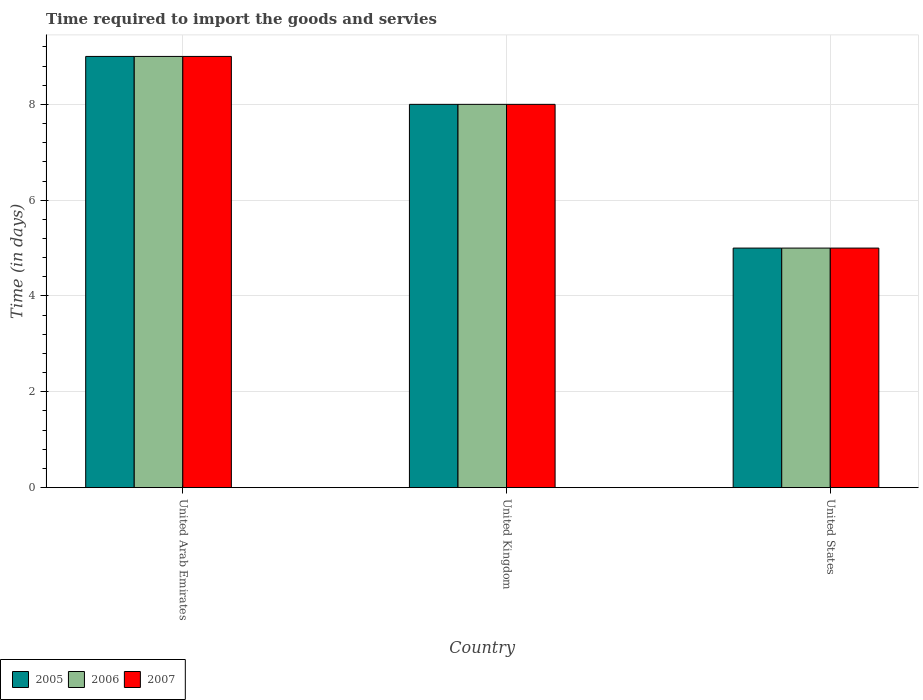Are the number of bars per tick equal to the number of legend labels?
Your answer should be compact. Yes. Are the number of bars on each tick of the X-axis equal?
Provide a succinct answer. Yes. How many bars are there on the 1st tick from the left?
Provide a succinct answer. 3. In how many cases, is the number of bars for a given country not equal to the number of legend labels?
Offer a terse response. 0. In which country was the number of days required to import the goods and services in 2006 maximum?
Make the answer very short. United Arab Emirates. What is the difference between the number of days required to import the goods and services in 2006 in United Kingdom and that in United States?
Your response must be concise. 3. What is the difference between the number of days required to import the goods and services in 2007 in United Arab Emirates and the number of days required to import the goods and services in 2005 in United Kingdom?
Make the answer very short. 1. What is the average number of days required to import the goods and services in 2005 per country?
Ensure brevity in your answer.  7.33. What is the difference between the number of days required to import the goods and services of/in 2005 and number of days required to import the goods and services of/in 2007 in United States?
Provide a short and direct response. 0. In how many countries, is the number of days required to import the goods and services in 2005 greater than 2.4 days?
Provide a succinct answer. 3. Is the difference between the number of days required to import the goods and services in 2005 in United Arab Emirates and United States greater than the difference between the number of days required to import the goods and services in 2007 in United Arab Emirates and United States?
Ensure brevity in your answer.  No. What is the difference between the highest and the lowest number of days required to import the goods and services in 2005?
Make the answer very short. 4. Is it the case that in every country, the sum of the number of days required to import the goods and services in 2007 and number of days required to import the goods and services in 2006 is greater than the number of days required to import the goods and services in 2005?
Your answer should be very brief. Yes. Are the values on the major ticks of Y-axis written in scientific E-notation?
Give a very brief answer. No. Does the graph contain any zero values?
Keep it short and to the point. No. Where does the legend appear in the graph?
Your response must be concise. Bottom left. What is the title of the graph?
Your response must be concise. Time required to import the goods and servies. Does "1993" appear as one of the legend labels in the graph?
Offer a terse response. No. What is the label or title of the X-axis?
Keep it short and to the point. Country. What is the label or title of the Y-axis?
Ensure brevity in your answer.  Time (in days). What is the Time (in days) of 2005 in United Arab Emirates?
Offer a terse response. 9. What is the Time (in days) in 2006 in United Arab Emirates?
Your answer should be compact. 9. What is the Time (in days) in 2005 in United Kingdom?
Your answer should be compact. 8. What is the Time (in days) in 2006 in United States?
Offer a terse response. 5. Across all countries, what is the maximum Time (in days) of 2007?
Give a very brief answer. 9. Across all countries, what is the minimum Time (in days) of 2006?
Your answer should be very brief. 5. What is the total Time (in days) in 2005 in the graph?
Make the answer very short. 22. What is the total Time (in days) of 2006 in the graph?
Offer a very short reply. 22. What is the difference between the Time (in days) of 2005 in United Arab Emirates and that in United Kingdom?
Offer a terse response. 1. What is the difference between the Time (in days) in 2007 in United Arab Emirates and that in United Kingdom?
Your response must be concise. 1. What is the difference between the Time (in days) in 2006 in United Kingdom and that in United States?
Your answer should be compact. 3. What is the difference between the Time (in days) of 2005 in United Arab Emirates and the Time (in days) of 2006 in United Kingdom?
Make the answer very short. 1. What is the difference between the Time (in days) in 2006 in United Arab Emirates and the Time (in days) in 2007 in United Kingdom?
Ensure brevity in your answer.  1. What is the difference between the Time (in days) of 2005 in United Arab Emirates and the Time (in days) of 2006 in United States?
Give a very brief answer. 4. What is the difference between the Time (in days) of 2006 in United Arab Emirates and the Time (in days) of 2007 in United States?
Make the answer very short. 4. What is the average Time (in days) of 2005 per country?
Make the answer very short. 7.33. What is the average Time (in days) of 2006 per country?
Provide a succinct answer. 7.33. What is the average Time (in days) of 2007 per country?
Give a very brief answer. 7.33. What is the difference between the Time (in days) of 2005 and Time (in days) of 2007 in United Kingdom?
Your answer should be very brief. 0. What is the difference between the Time (in days) in 2005 and Time (in days) in 2006 in United States?
Your response must be concise. 0. What is the difference between the Time (in days) of 2006 and Time (in days) of 2007 in United States?
Your answer should be very brief. 0. What is the ratio of the Time (in days) of 2005 in United Arab Emirates to that in United Kingdom?
Your response must be concise. 1.12. What is the ratio of the Time (in days) in 2007 in United Arab Emirates to that in United Kingdom?
Ensure brevity in your answer.  1.12. What is the ratio of the Time (in days) of 2005 in United Arab Emirates to that in United States?
Give a very brief answer. 1.8. What is the ratio of the Time (in days) in 2006 in United Arab Emirates to that in United States?
Your answer should be very brief. 1.8. What is the ratio of the Time (in days) in 2007 in United Arab Emirates to that in United States?
Your answer should be very brief. 1.8. What is the ratio of the Time (in days) in 2006 in United Kingdom to that in United States?
Keep it short and to the point. 1.6. What is the difference between the highest and the second highest Time (in days) in 2005?
Give a very brief answer. 1. What is the difference between the highest and the second highest Time (in days) of 2006?
Your answer should be compact. 1. What is the difference between the highest and the lowest Time (in days) of 2005?
Offer a terse response. 4. 